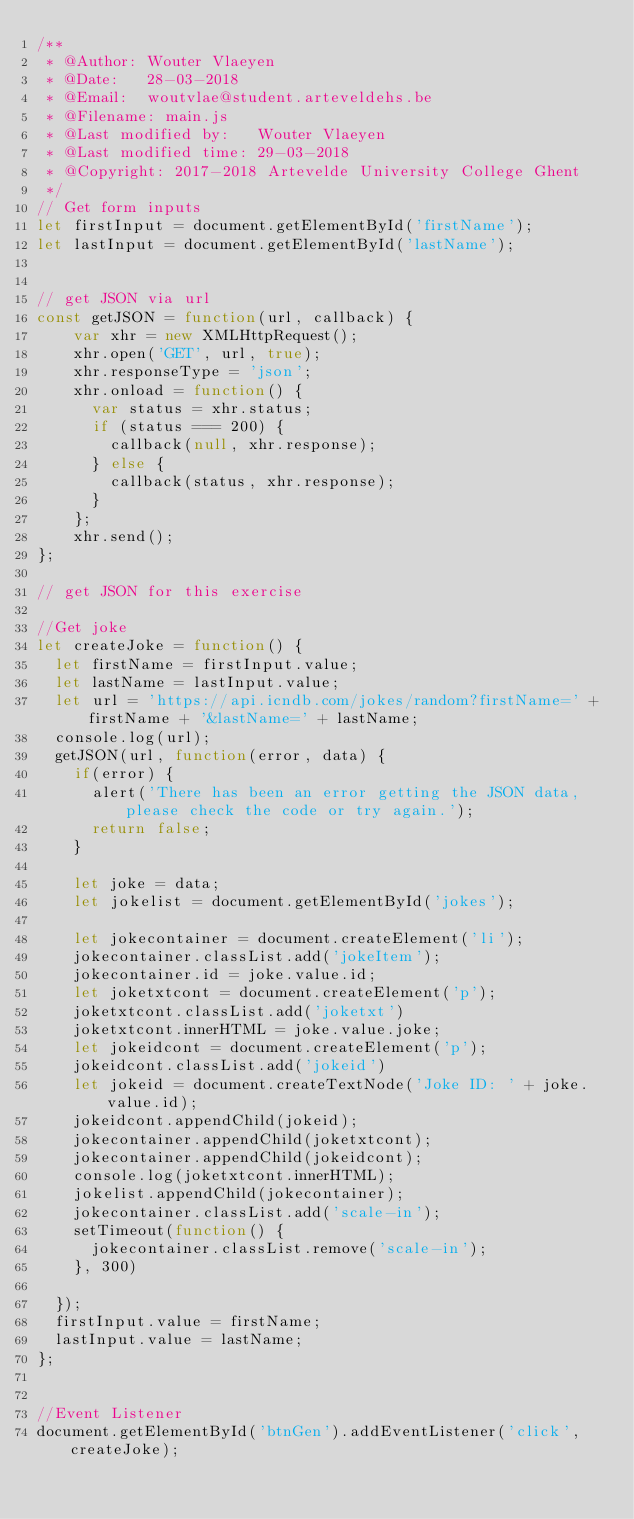<code> <loc_0><loc_0><loc_500><loc_500><_JavaScript_>/**
 * @Author: Wouter Vlaeyen
 * @Date:   28-03-2018
 * @Email:  woutvlae@student.arteveldehs.be
 * @Filename: main.js
 * @Last modified by:   Wouter Vlaeyen
 * @Last modified time: 29-03-2018
 * @Copyright: 2017-2018 Artevelde University College Ghent
 */
// Get form inputs
let firstInput = document.getElementById('firstName');
let lastInput = document.getElementById('lastName');


// get JSON via url
const getJSON = function(url, callback) {
    var xhr = new XMLHttpRequest();
    xhr.open('GET', url, true);
    xhr.responseType = 'json';
    xhr.onload = function() {
      var status = xhr.status;
      if (status === 200) {
        callback(null, xhr.response);
      } else {
        callback(status, xhr.response);
      }
    };
    xhr.send();
};

// get JSON for this exercise

//Get joke
let createJoke = function() {
  let firstName = firstInput.value;
  let lastName = lastInput.value;
  let url = 'https://api.icndb.com/jokes/random?firstName=' + firstName + '&lastName=' + lastName;
  console.log(url);
  getJSON(url, function(error, data) {
    if(error) {
      alert('There has been an error getting the JSON data, please check the code or try again.');
      return false;
    }

    let joke = data;
    let jokelist = document.getElementById('jokes');

    let jokecontainer = document.createElement('li');
    jokecontainer.classList.add('jokeItem');
    jokecontainer.id = joke.value.id;
    let joketxtcont = document.createElement('p');
    joketxtcont.classList.add('joketxt')
    joketxtcont.innerHTML = joke.value.joke;
    let jokeidcont = document.createElement('p');
    jokeidcont.classList.add('jokeid')
    let jokeid = document.createTextNode('Joke ID: ' + joke.value.id);
    jokeidcont.appendChild(jokeid);
    jokecontainer.appendChild(joketxtcont);
    jokecontainer.appendChild(jokeidcont);
    console.log(joketxtcont.innerHTML);
    jokelist.appendChild(jokecontainer);
    jokecontainer.classList.add('scale-in');
    setTimeout(function() {
      jokecontainer.classList.remove('scale-in');
    }, 300)

  });
  firstInput.value = firstName;
  lastInput.value = lastName;
};


//Event Listener
document.getElementById('btnGen').addEventListener('click', createJoke);
</code> 